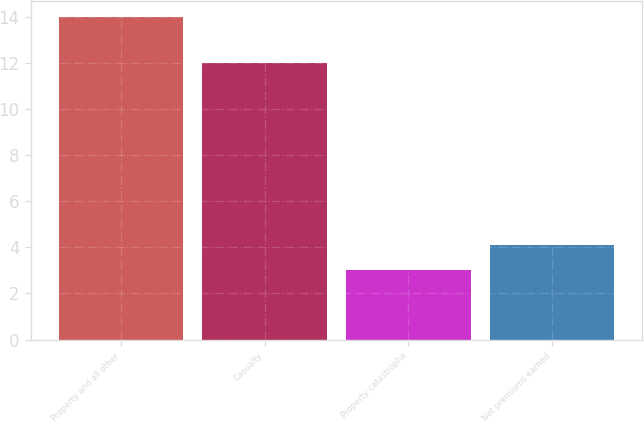Convert chart. <chart><loc_0><loc_0><loc_500><loc_500><bar_chart><fcel>Property and all other<fcel>Casualty<fcel>Property catastrophe<fcel>Net premiums earned<nl><fcel>14<fcel>12<fcel>3<fcel>4.1<nl></chart> 